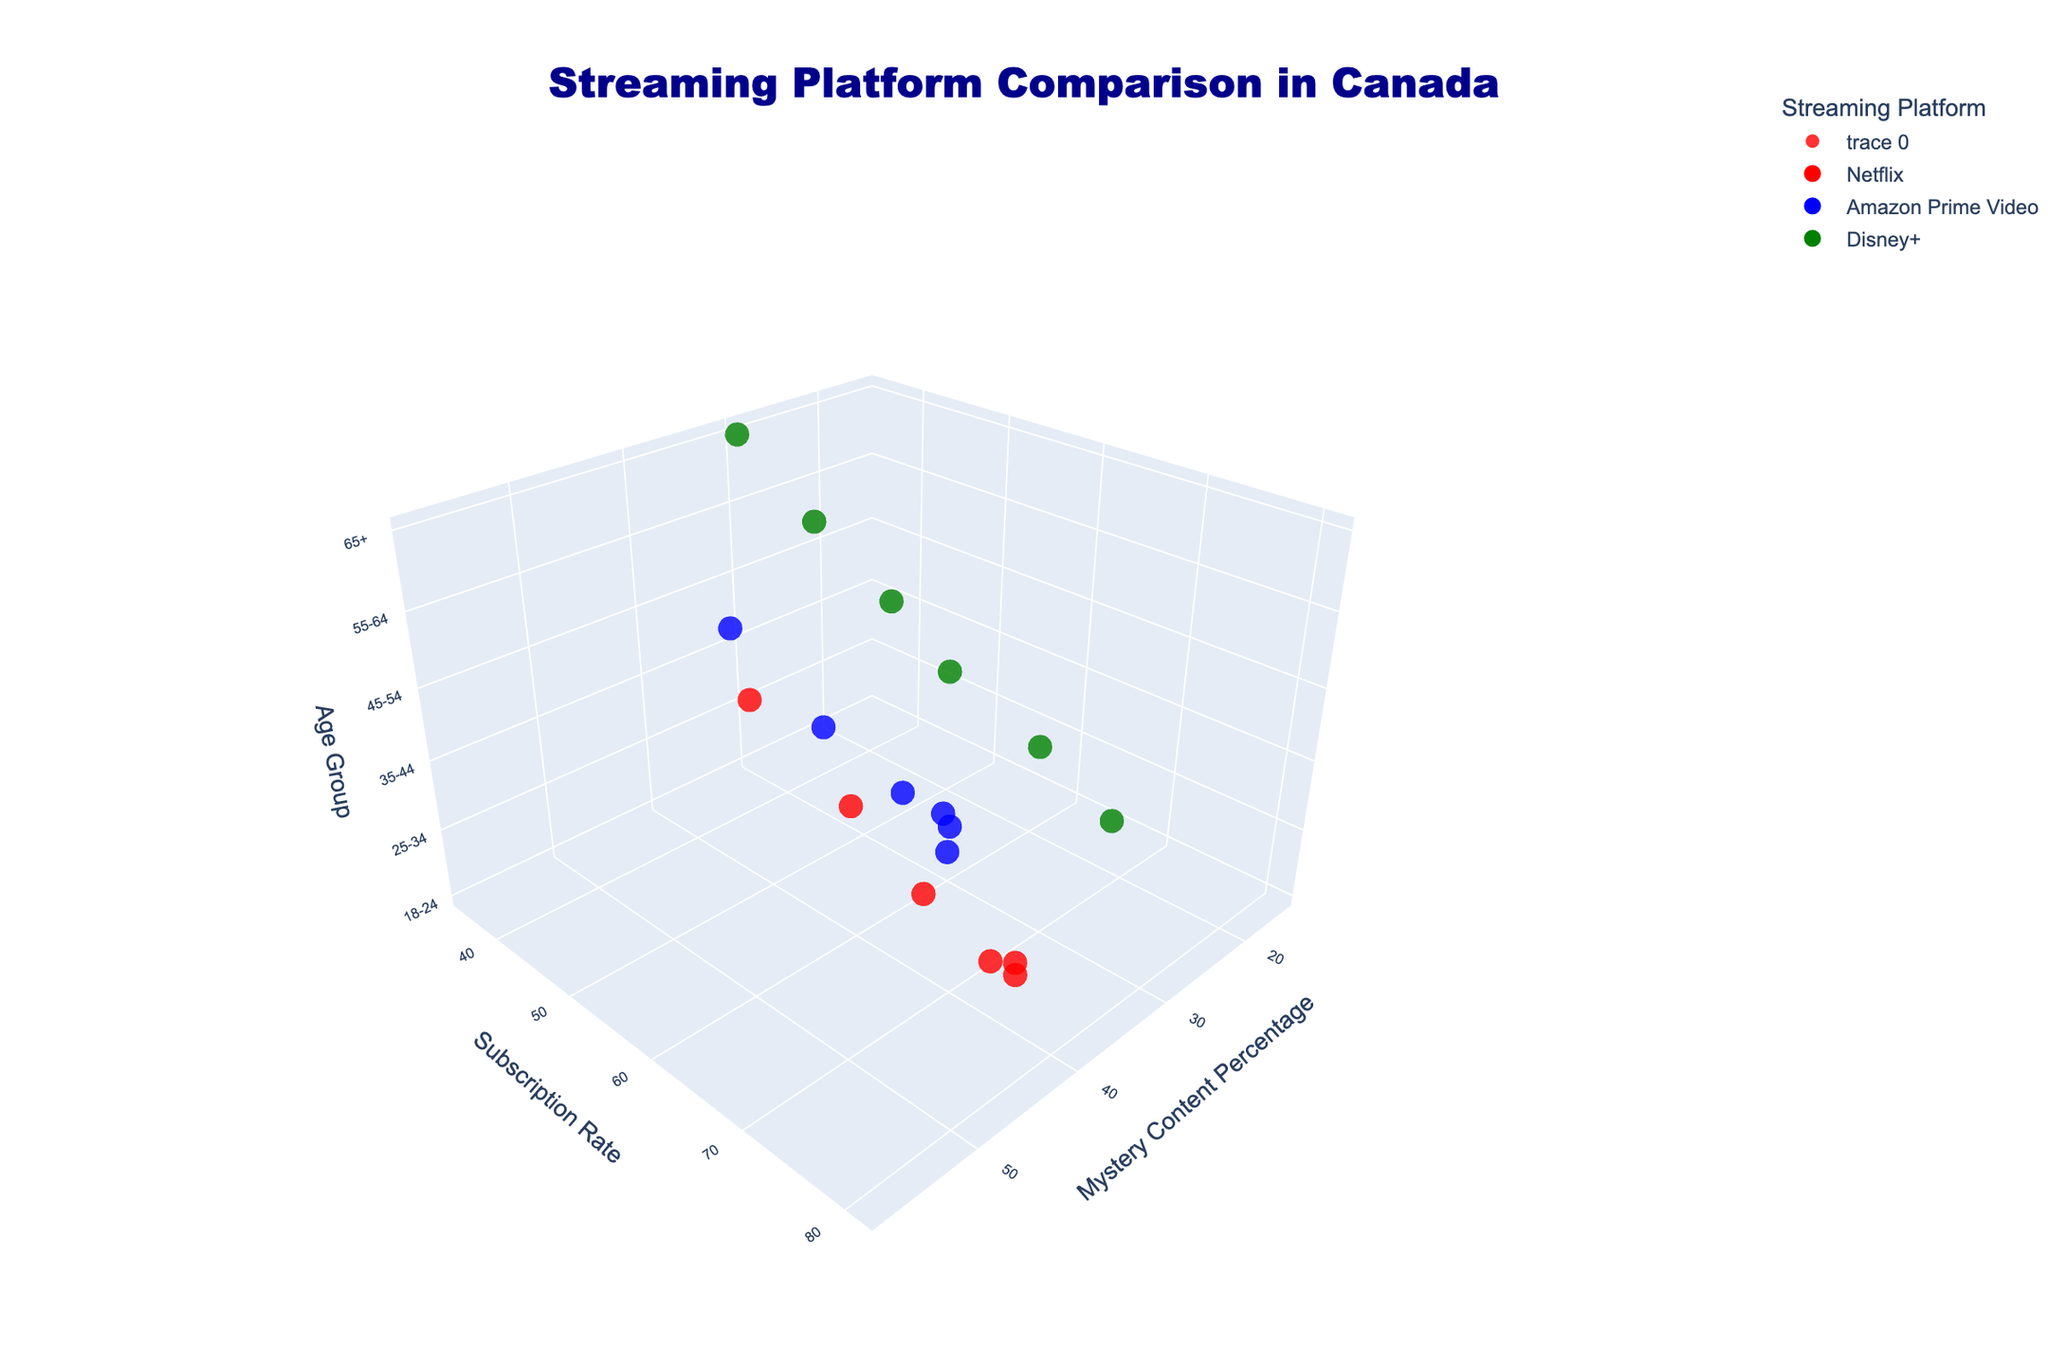What's the title of the 3D plot? The title is usually located at the top of the plot and can be easily identified. In this case, it reads "Streaming Platform Comparison in Canada".
Answer: Streaming Platform Comparison in Canada Which platform has the highest mystery content percentage among the 25-34 age group? By observing the plot along the z-axis for the 25-34 age group and looking at the x-axis for the mystery content percentage, Netflix has the highest value.
Answer: Netflix Which streaming platform has the lowest subscription rate across all age groups? By observing the y-axis for subscription rates across all age groups, Disney+ consistently has the lowest values.
Answer: Disney+ What’s the trend in subscription rates for Netflix as age group increases? By observing the z-axis (age group) and the corresponding y-axis (subscription rate) for Netflix (red markers), as the age group increases, the subscription rates also tend to increase.
Answer: Increases Compare the mystery content percentage between 45-54 age group and 55-64 age group for Amazon Prime Video. Which has a higher percentage? For the age group 45-54, Amazon Prime Video has a mystery content percentage of 45, while for 55-64, it is 50.
Answer: 55-64 age group What is the approximate subscription rate for Disney+ in the 18-24 age group compared to the 25-34 age group? By checking the z-axis for 18-24 and 25-34 age groups and correlating the y-axis for Disney+ (green markers), the subscription rates are approximately 65 for 18-24 and 59 for 25-34.
Answer: 65 for 18-24 and 59 for 25-34 What age group shows the highest interest in mystery content for Amazon Prime Video? Looking at the x-axis (Mystery Content Percentage) and z-axis (age groups) for Amazon Prime Video (blue markers), the 65+ age group shows the highest interest with a percentage of 53.
Answer: 65+ How does the trend in mystery content percentage change for Disney+ across different age groups? Observing the x-axis for Disney+ (green markers) across different z-axis (age groups), the mystery content percentage consistently increases as age group increases.
Answer: Increases Which age group has the highest subscription rate for Amazon Prime Video? By examining the z-axis (age group) and the y-axis (subscription rate) for Amazon Prime Video (blue markers), the 45-54 age group has the highest subscription rate.
Answer: 45-54 age group 